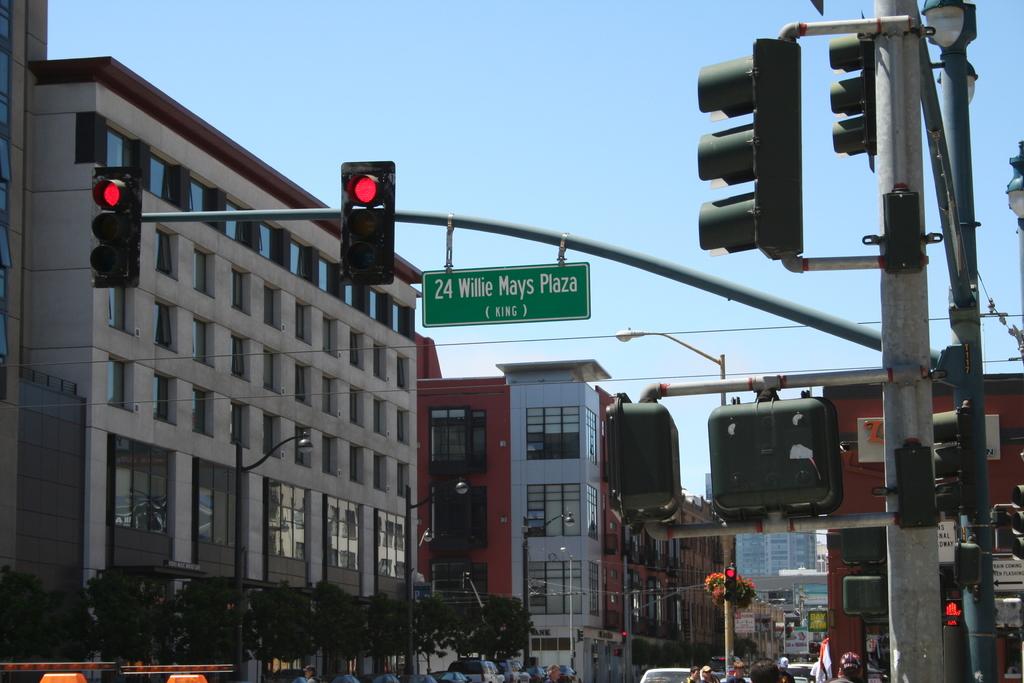What is the street name?
Provide a short and direct response. Willie mays plaza. 